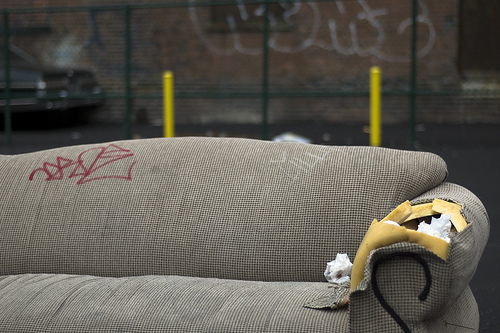<image>
Is there a grafitti behind the car? Yes. From this viewpoint, the grafitti is positioned behind the car, with the car partially or fully occluding the grafitti. 